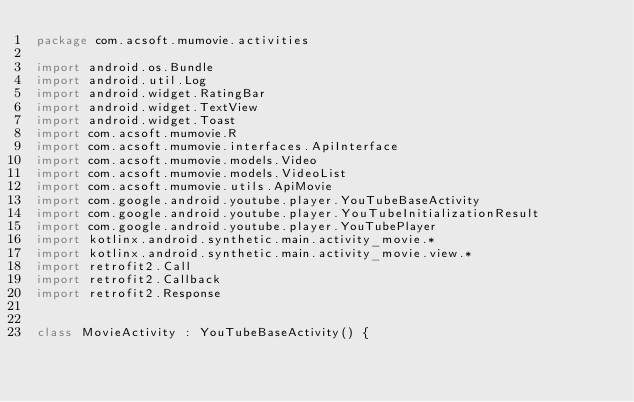<code> <loc_0><loc_0><loc_500><loc_500><_Kotlin_>package com.acsoft.mumovie.activities

import android.os.Bundle
import android.util.Log
import android.widget.RatingBar
import android.widget.TextView
import android.widget.Toast
import com.acsoft.mumovie.R
import com.acsoft.mumovie.interfaces.ApiInterface
import com.acsoft.mumovie.models.Video
import com.acsoft.mumovie.models.VideoList
import com.acsoft.mumovie.utils.ApiMovie
import com.google.android.youtube.player.YouTubeBaseActivity
import com.google.android.youtube.player.YouTubeInitializationResult
import com.google.android.youtube.player.YouTubePlayer
import kotlinx.android.synthetic.main.activity_movie.*
import kotlinx.android.synthetic.main.activity_movie.view.*
import retrofit2.Call
import retrofit2.Callback
import retrofit2.Response


class MovieActivity : YouTubeBaseActivity() {
</code> 